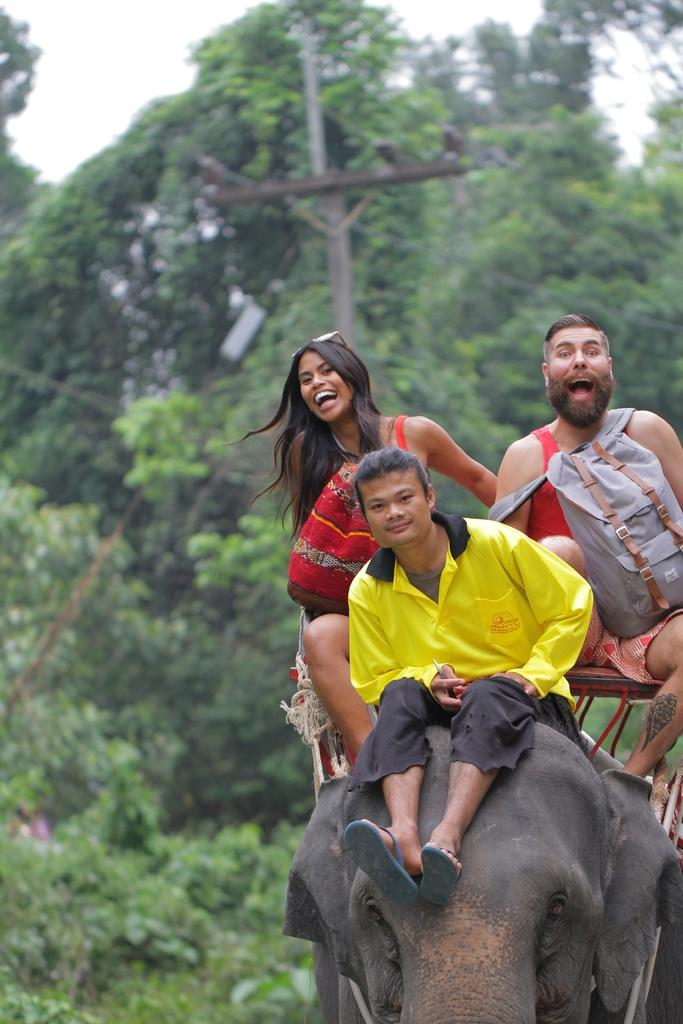How many people are in the image? There are three persons in the image. What are the persons doing in the image? The persons are sitting on an elephant. What can be seen in the background of the image? There are trees visible in the image. What object is present in the image that is not related to the persons or the elephant? There is a pole in the image. What is one person carrying in the image? One person is carrying a bag. What type of grip does the elephant have on the bells in the image? There are no bells present in the image, so it is not possible to determine the type of grip the elephant has on them. 